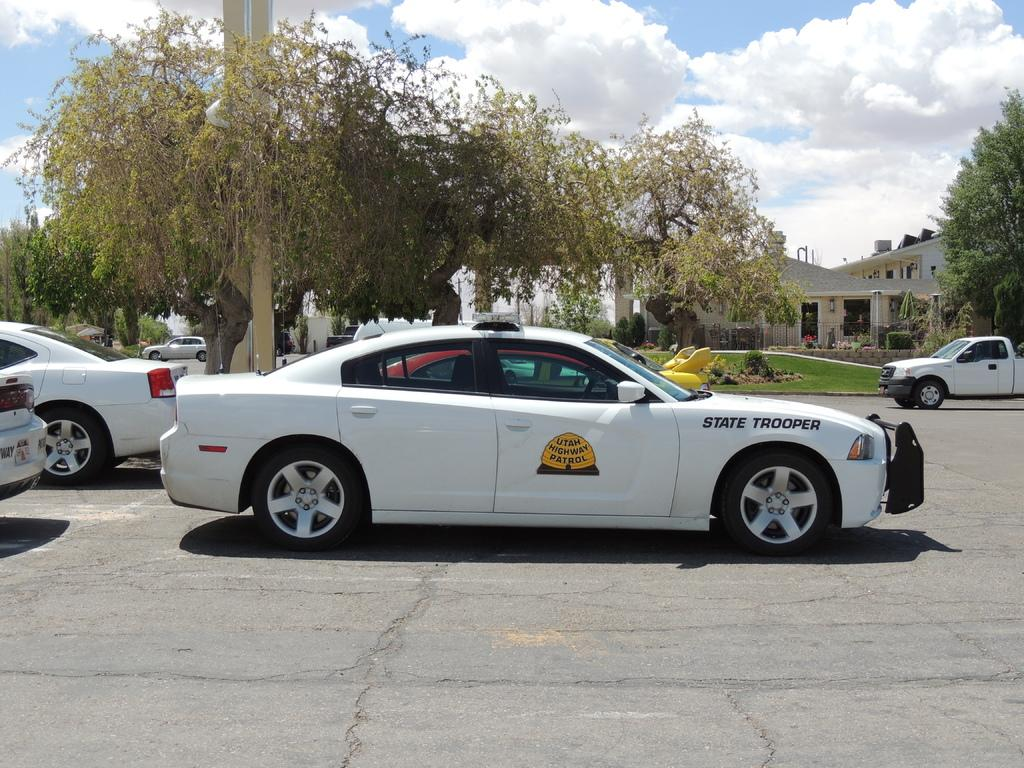What types of objects can be seen in the image? There are vehicles, trees, houses, and poles in the image. Can you describe the color of the sky in the image? The sky is blue and white in color. How much honey is being used by the beginner in the image? There is no mention of honey or a beginner in the image, so this question cannot be answered. 